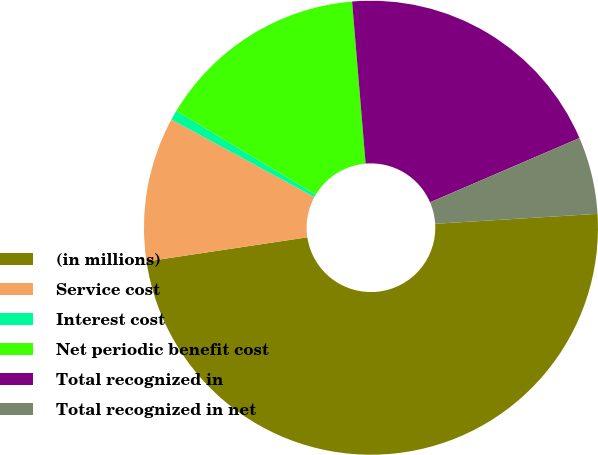Convert chart to OTSL. <chart><loc_0><loc_0><loc_500><loc_500><pie_chart><fcel>(in millions)<fcel>Service cost<fcel>Interest cost<fcel>Net periodic benefit cost<fcel>Total recognized in<fcel>Total recognized in net<nl><fcel>48.6%<fcel>10.28%<fcel>0.7%<fcel>15.07%<fcel>19.86%<fcel>5.49%<nl></chart> 